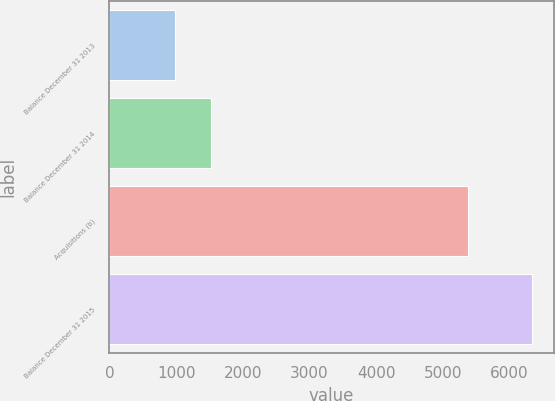Convert chart to OTSL. <chart><loc_0><loc_0><loc_500><loc_500><bar_chart><fcel>Balance December 31 2013<fcel>Balance December 31 2014<fcel>Acquisitions (b)<fcel>Balance December 31 2015<nl><fcel>982<fcel>1518.2<fcel>5373<fcel>6344<nl></chart> 